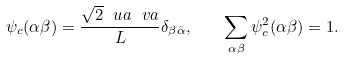Convert formula to latex. <formula><loc_0><loc_0><loc_500><loc_500>\psi _ { c } ( \alpha \beta ) = \frac { \sqrt { 2 } \ u a \ v a } { L } \delta _ { \beta \tilde { \alpha } } , \quad \sum _ { \alpha \beta } \psi _ { c } ^ { 2 } ( \alpha \beta ) = 1 .</formula> 